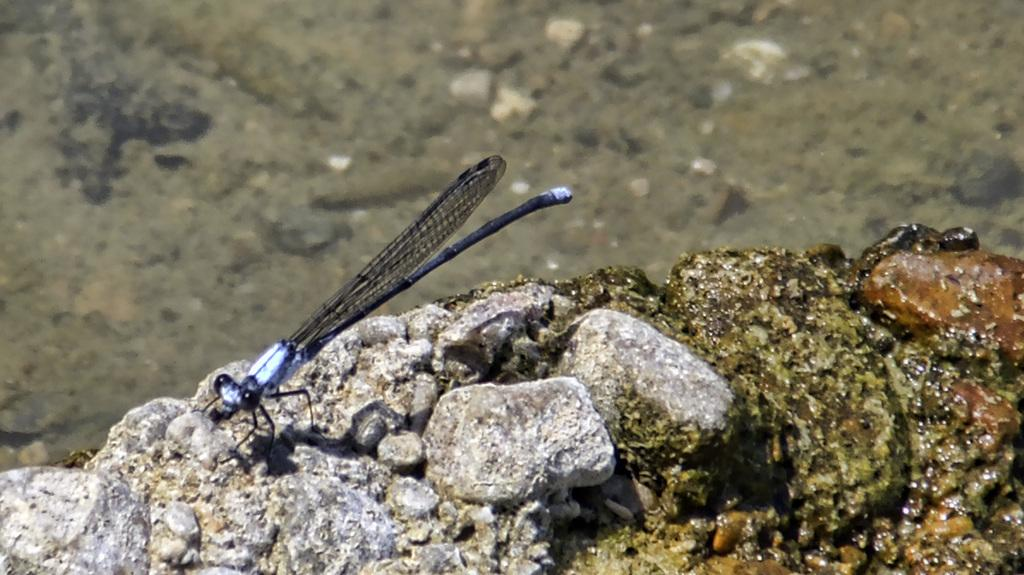What type of creature can be seen in the picture? There is an insect in the picture. What is present at the bottom of the picture? There are stones and rocks at the bottom of the picture. Can you describe the background of the image? The background of the image is green and blurred. How does the flame affect the behavior of the cows in the image? There are no cows or flames present in the image, so this question cannot be answered. 